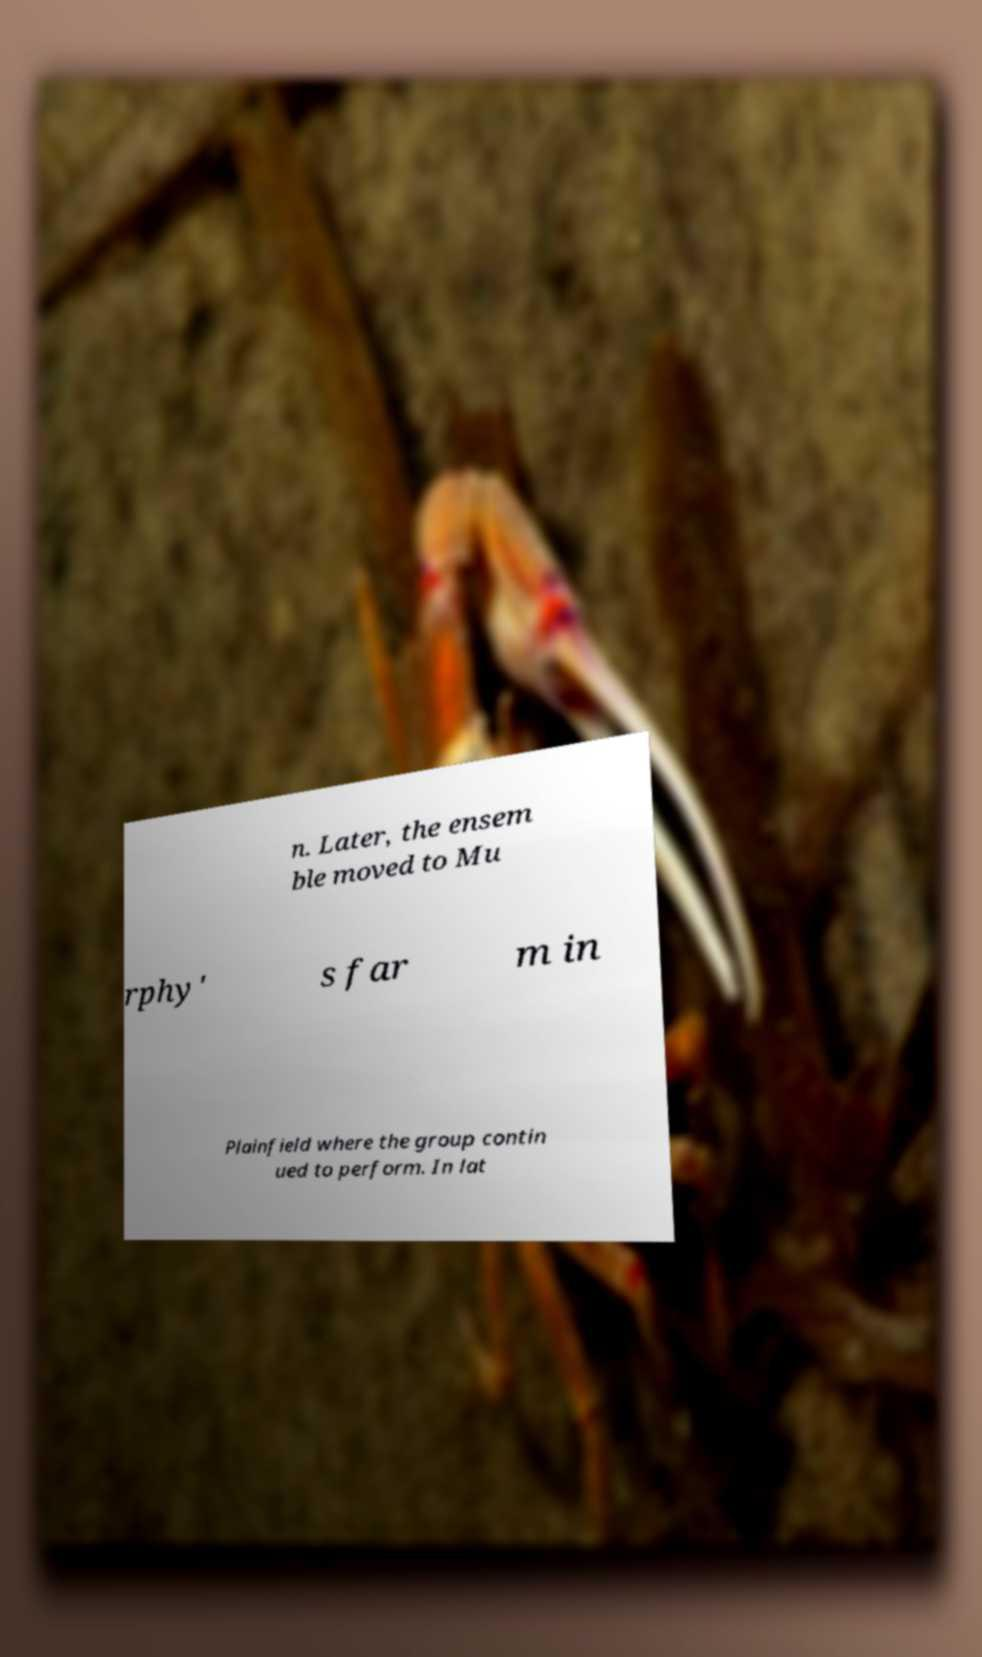Can you read and provide the text displayed in the image?This photo seems to have some interesting text. Can you extract and type it out for me? n. Later, the ensem ble moved to Mu rphy' s far m in Plainfield where the group contin ued to perform. In lat 